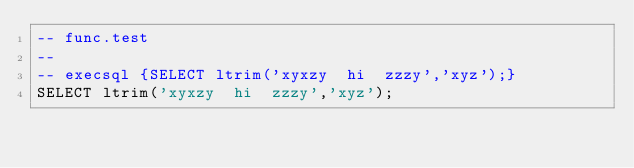Convert code to text. <code><loc_0><loc_0><loc_500><loc_500><_SQL_>-- func.test
-- 
-- execsql {SELECT ltrim('xyxzy  hi  zzzy','xyz');}
SELECT ltrim('xyxzy  hi  zzzy','xyz');</code> 